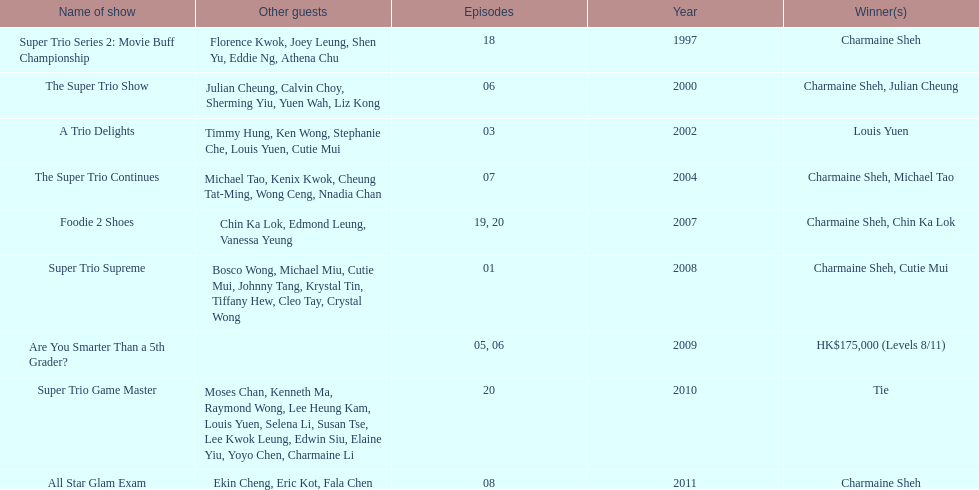How many of shows had at least 5 episodes? 7. 